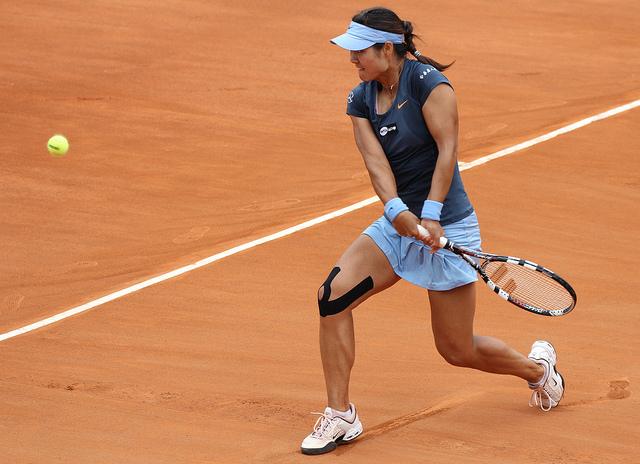Why is she biting her lip?
Write a very short answer. Concentrating. Why do the woman's feet seem to be off of the ground?
Short answer required. No. What sport is being played?
Concise answer only. Tennis. Is one of her hands touching the ground?
Give a very brief answer. No. Is this motion similar to how people handle oars?
Keep it brief. No. What surface is the woman jumping on?
Be succinct. Sand. 